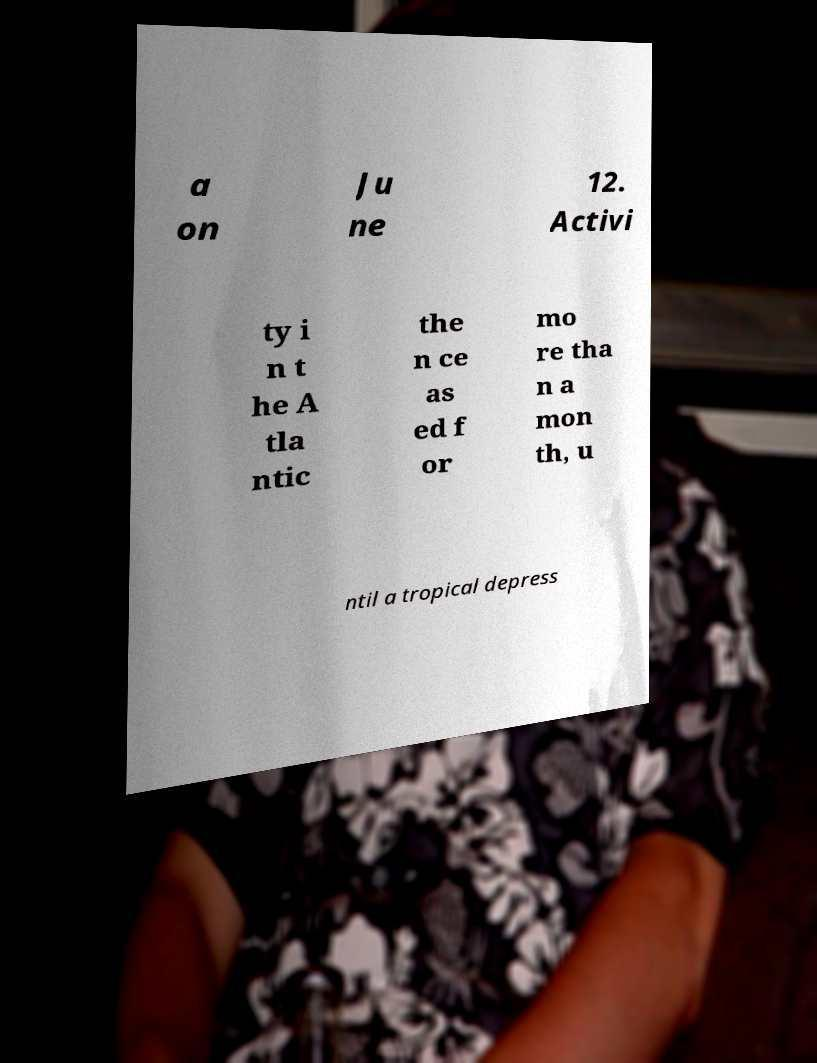What messages or text are displayed in this image? I need them in a readable, typed format. a on Ju ne 12. Activi ty i n t he A tla ntic the n ce as ed f or mo re tha n a mon th, u ntil a tropical depress 